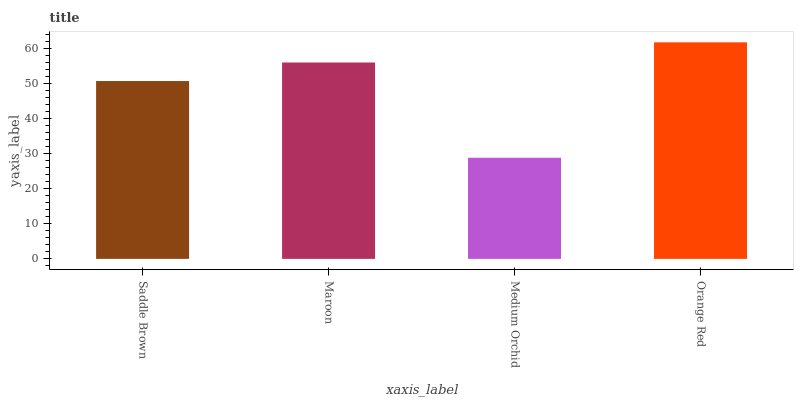Is Medium Orchid the minimum?
Answer yes or no. Yes. Is Orange Red the maximum?
Answer yes or no. Yes. Is Maroon the minimum?
Answer yes or no. No. Is Maroon the maximum?
Answer yes or no. No. Is Maroon greater than Saddle Brown?
Answer yes or no. Yes. Is Saddle Brown less than Maroon?
Answer yes or no. Yes. Is Saddle Brown greater than Maroon?
Answer yes or no. No. Is Maroon less than Saddle Brown?
Answer yes or no. No. Is Maroon the high median?
Answer yes or no. Yes. Is Saddle Brown the low median?
Answer yes or no. Yes. Is Orange Red the high median?
Answer yes or no. No. Is Medium Orchid the low median?
Answer yes or no. No. 